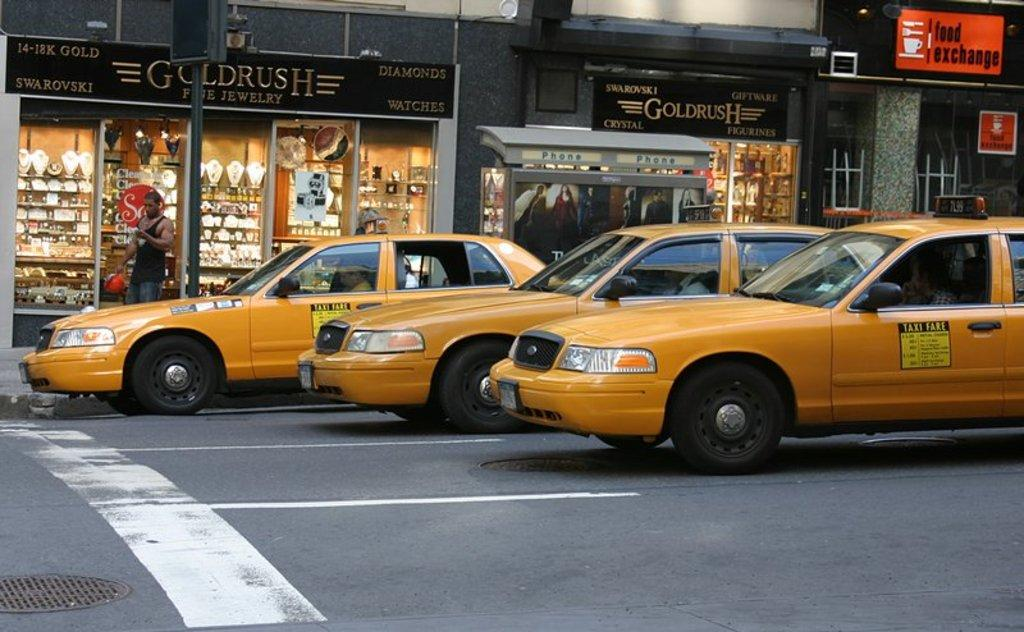<image>
Share a concise interpretation of the image provided. A bunch of taxis in front of a sign that says 14-18K Swarovski. 